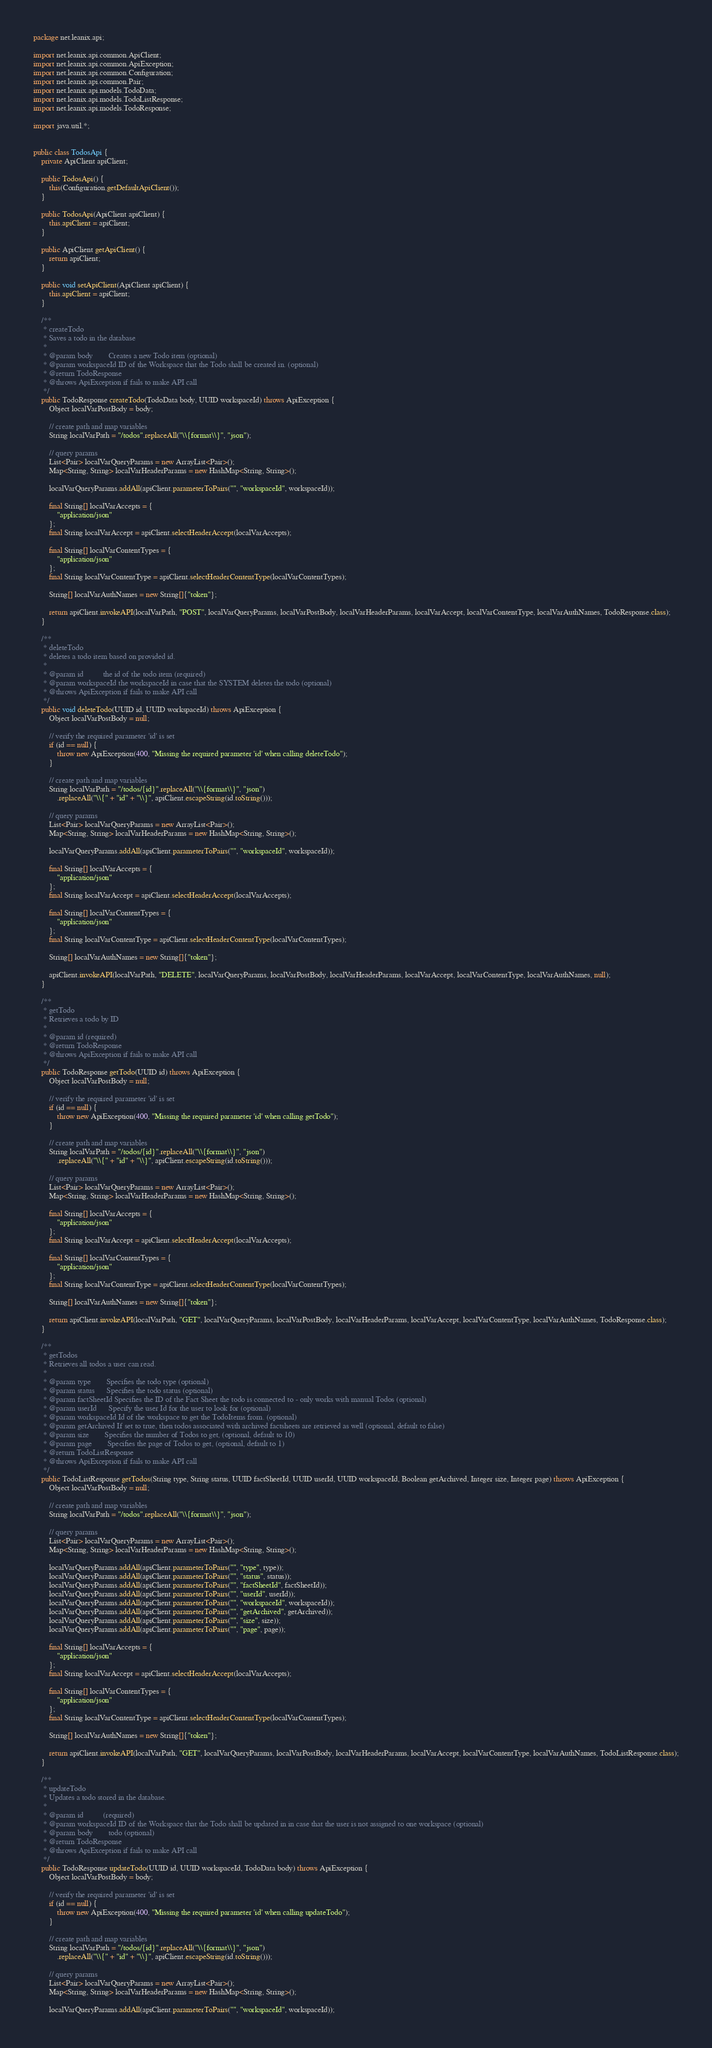<code> <loc_0><loc_0><loc_500><loc_500><_Java_>package net.leanix.api;

import net.leanix.api.common.ApiClient;
import net.leanix.api.common.ApiException;
import net.leanix.api.common.Configuration;
import net.leanix.api.common.Pair;
import net.leanix.api.models.TodoData;
import net.leanix.api.models.TodoListResponse;
import net.leanix.api.models.TodoResponse;

import java.util.*;


public class TodosApi {
    private ApiClient apiClient;

    public TodosApi() {
        this(Configuration.getDefaultApiClient());
    }

    public TodosApi(ApiClient apiClient) {
        this.apiClient = apiClient;
    }

    public ApiClient getApiClient() {
        return apiClient;
    }

    public void setApiClient(ApiClient apiClient) {
        this.apiClient = apiClient;
    }

    /**
     * createTodo
     * Saves a todo in the database
     *
     * @param body        Creates a new Todo item (optional)
     * @param workspaceId ID of the Workspace that the Todo shall be created in. (optional)
     * @return TodoResponse
     * @throws ApiException if fails to make API call
     */
    public TodoResponse createTodo(TodoData body, UUID workspaceId) throws ApiException {
        Object localVarPostBody = body;

        // create path and map variables
        String localVarPath = "/todos".replaceAll("\\{format\\}", "json");

        // query params
        List<Pair> localVarQueryParams = new ArrayList<Pair>();
        Map<String, String> localVarHeaderParams = new HashMap<String, String>();

        localVarQueryParams.addAll(apiClient.parameterToPairs("", "workspaceId", workspaceId));

        final String[] localVarAccepts = {
            "application/json"
        };
        final String localVarAccept = apiClient.selectHeaderAccept(localVarAccepts);

        final String[] localVarContentTypes = {
            "application/json"
        };
        final String localVarContentType = apiClient.selectHeaderContentType(localVarContentTypes);

        String[] localVarAuthNames = new String[]{"token"};

        return apiClient.invokeAPI(localVarPath, "POST", localVarQueryParams, localVarPostBody, localVarHeaderParams, localVarAccept, localVarContentType, localVarAuthNames, TodoResponse.class);
    }

    /**
     * deleteTodo
     * deletes a todo item based on provided id.
     *
     * @param id          the id of the todo item (required)
     * @param workspaceId the workspaceId in case that the SYSTEM deletes the todo (optional)
     * @throws ApiException if fails to make API call
     */
    public void deleteTodo(UUID id, UUID workspaceId) throws ApiException {
        Object localVarPostBody = null;

        // verify the required parameter 'id' is set
        if (id == null) {
            throw new ApiException(400, "Missing the required parameter 'id' when calling deleteTodo");
        }

        // create path and map variables
        String localVarPath = "/todos/{id}".replaceAll("\\{format\\}", "json")
            .replaceAll("\\{" + "id" + "\\}", apiClient.escapeString(id.toString()));

        // query params
        List<Pair> localVarQueryParams = new ArrayList<Pair>();
        Map<String, String> localVarHeaderParams = new HashMap<String, String>();

        localVarQueryParams.addAll(apiClient.parameterToPairs("", "workspaceId", workspaceId));

        final String[] localVarAccepts = {
            "application/json"
        };
        final String localVarAccept = apiClient.selectHeaderAccept(localVarAccepts);

        final String[] localVarContentTypes = {
            "application/json"
        };
        final String localVarContentType = apiClient.selectHeaderContentType(localVarContentTypes);

        String[] localVarAuthNames = new String[]{"token"};

        apiClient.invokeAPI(localVarPath, "DELETE", localVarQueryParams, localVarPostBody, localVarHeaderParams, localVarAccept, localVarContentType, localVarAuthNames, null);
    }

    /**
     * getTodo
     * Retrieves a todo by ID
     *
     * @param id (required)
     * @return TodoResponse
     * @throws ApiException if fails to make API call
     */
    public TodoResponse getTodo(UUID id) throws ApiException {
        Object localVarPostBody = null;

        // verify the required parameter 'id' is set
        if (id == null) {
            throw new ApiException(400, "Missing the required parameter 'id' when calling getTodo");
        }

        // create path and map variables
        String localVarPath = "/todos/{id}".replaceAll("\\{format\\}", "json")
            .replaceAll("\\{" + "id" + "\\}", apiClient.escapeString(id.toString()));

        // query params
        List<Pair> localVarQueryParams = new ArrayList<Pair>();
        Map<String, String> localVarHeaderParams = new HashMap<String, String>();

        final String[] localVarAccepts = {
            "application/json"
        };
        final String localVarAccept = apiClient.selectHeaderAccept(localVarAccepts);

        final String[] localVarContentTypes = {
            "application/json"
        };
        final String localVarContentType = apiClient.selectHeaderContentType(localVarContentTypes);

        String[] localVarAuthNames = new String[]{"token"};

        return apiClient.invokeAPI(localVarPath, "GET", localVarQueryParams, localVarPostBody, localVarHeaderParams, localVarAccept, localVarContentType, localVarAuthNames, TodoResponse.class);
    }

    /**
     * getTodos
     * Retrieves all todos a user can read.
     *
     * @param type        Specifies the todo type (optional)
     * @param status      Specifies the todo status (optional)
     * @param factSheetId Specifies the ID of the Fact Sheet the todo is connected to - only works with manual Todos (optional)
     * @param userId      Specify the user Id for the user to look for (optional)
     * @param workspaceId Id of the workspace to get the TodoItems from. (optional)
     * @param getArchived If set to true, then todos associated with archived factsheets are retrieved as well (optional, default to false)
     * @param size        Specifies the number of Todos to get, (optional, default to 10)
     * @param page        Specifies the page of Todos to get, (optional, default to 1)
     * @return TodoListResponse
     * @throws ApiException if fails to make API call
     */
    public TodoListResponse getTodos(String type, String status, UUID factSheetId, UUID userId, UUID workspaceId, Boolean getArchived, Integer size, Integer page) throws ApiException {
        Object localVarPostBody = null;

        // create path and map variables
        String localVarPath = "/todos".replaceAll("\\{format\\}", "json");

        // query params
        List<Pair> localVarQueryParams = new ArrayList<Pair>();
        Map<String, String> localVarHeaderParams = new HashMap<String, String>();

        localVarQueryParams.addAll(apiClient.parameterToPairs("", "type", type));
        localVarQueryParams.addAll(apiClient.parameterToPairs("", "status", status));
        localVarQueryParams.addAll(apiClient.parameterToPairs("", "factSheetId", factSheetId));
        localVarQueryParams.addAll(apiClient.parameterToPairs("", "userId", userId));
        localVarQueryParams.addAll(apiClient.parameterToPairs("", "workspaceId", workspaceId));
        localVarQueryParams.addAll(apiClient.parameterToPairs("", "getArchived", getArchived));
        localVarQueryParams.addAll(apiClient.parameterToPairs("", "size", size));
        localVarQueryParams.addAll(apiClient.parameterToPairs("", "page", page));

        final String[] localVarAccepts = {
            "application/json"
        };
        final String localVarAccept = apiClient.selectHeaderAccept(localVarAccepts);

        final String[] localVarContentTypes = {
            "application/json"
        };
        final String localVarContentType = apiClient.selectHeaderContentType(localVarContentTypes);

        String[] localVarAuthNames = new String[]{"token"};

        return apiClient.invokeAPI(localVarPath, "GET", localVarQueryParams, localVarPostBody, localVarHeaderParams, localVarAccept, localVarContentType, localVarAuthNames, TodoListResponse.class);
    }

    /**
     * updateTodo
     * Updates a todo stored in the database.
     *
     * @param id          (required)
     * @param workspaceId ID of the Workspace that the Todo shall be updated in in case that the user is not assigned to one workspace (optional)
     * @param body        todo (optional)
     * @return TodoResponse
     * @throws ApiException if fails to make API call
     */
    public TodoResponse updateTodo(UUID id, UUID workspaceId, TodoData body) throws ApiException {
        Object localVarPostBody = body;

        // verify the required parameter 'id' is set
        if (id == null) {
            throw new ApiException(400, "Missing the required parameter 'id' when calling updateTodo");
        }

        // create path and map variables
        String localVarPath = "/todos/{id}".replaceAll("\\{format\\}", "json")
            .replaceAll("\\{" + "id" + "\\}", apiClient.escapeString(id.toString()));

        // query params
        List<Pair> localVarQueryParams = new ArrayList<Pair>();
        Map<String, String> localVarHeaderParams = new HashMap<String, String>();

        localVarQueryParams.addAll(apiClient.parameterToPairs("", "workspaceId", workspaceId));
</code> 